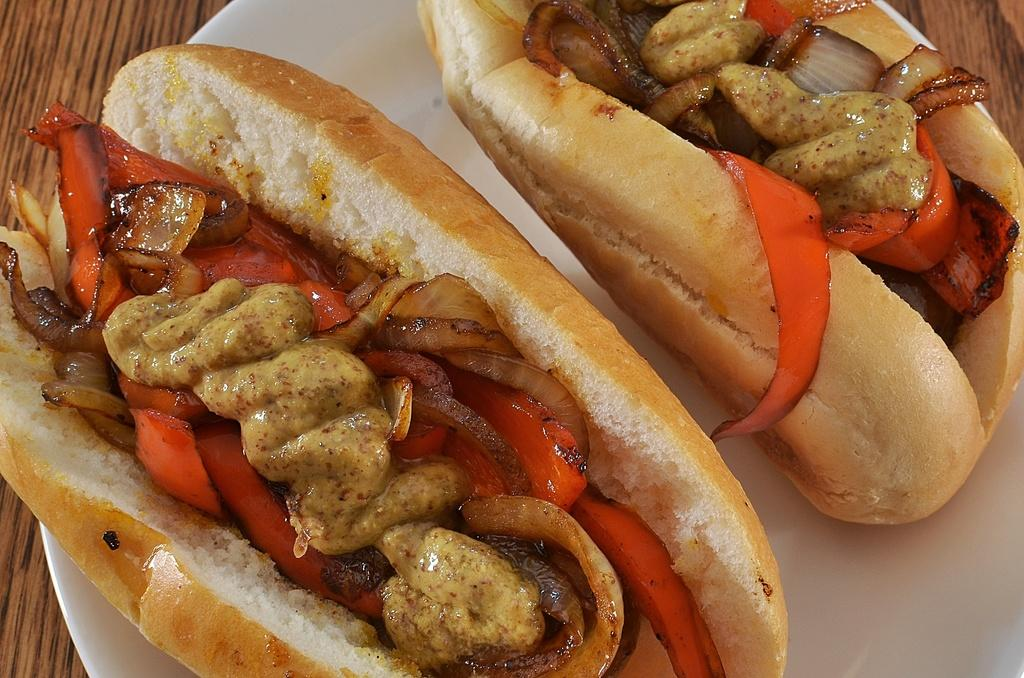How many burgers are visible in the image? There are two burgers in the image. What is the color of the plate on which the burgers are placed? The plate is white. Where is the plate with the burgers located? The plate is on a table. What type of game is being played with the burgers in the image? There is no game being played with the burgers in the image; they are simply on a plate. 